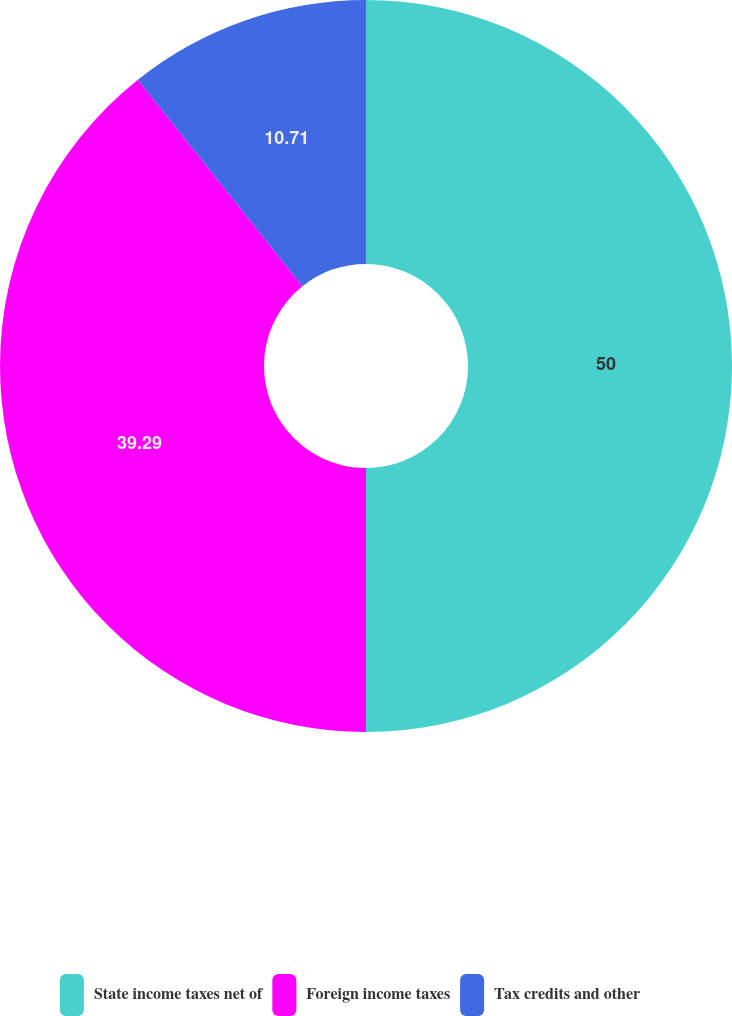Convert chart to OTSL. <chart><loc_0><loc_0><loc_500><loc_500><pie_chart><fcel>State income taxes net of<fcel>Foreign income taxes<fcel>Tax credits and other<nl><fcel>50.0%<fcel>39.29%<fcel>10.71%<nl></chart> 